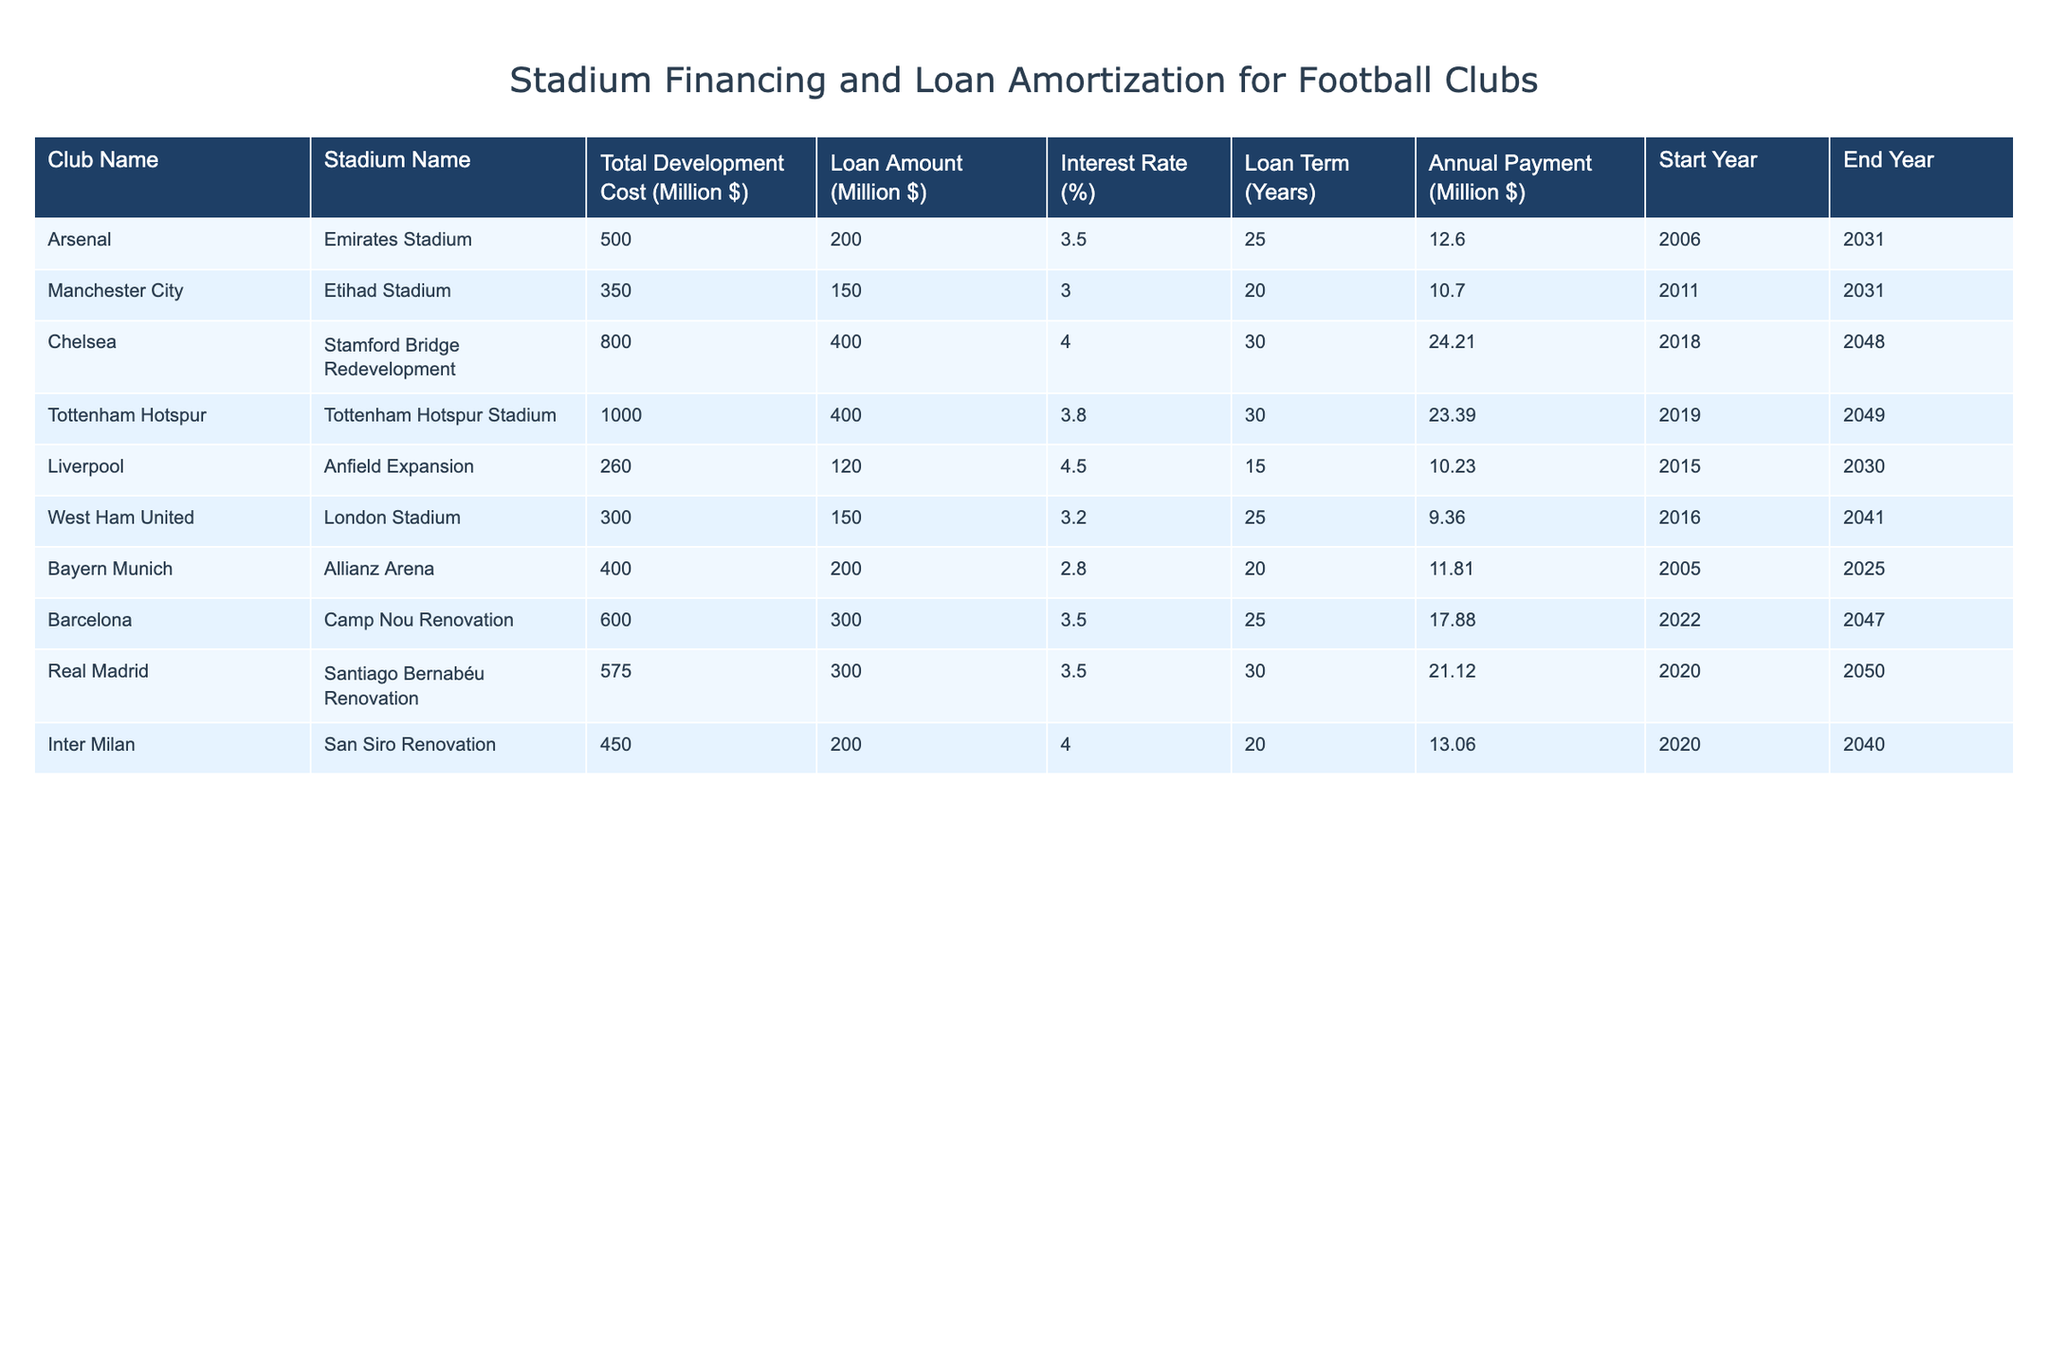What is the total development cost of the Tottenham Hotspur Stadium? The table indicates that the total development cost for the Tottenham Hotspur Stadium is listed directly in the column for 'Total Development Cost (Million $)'. It shows as 1000.
Answer: 1000 What is the loan amount for Chelsea's stadium redevelopment? By referring to the 'Loan Amount (Million $)' column for Chelsea, we can see that it is listed as 400.
Answer: 400 Which stadium has the highest interest rate on its loan? To determine this, we compare the 'Interest Rate (%)' across all listed stadiums. Chelsea's Stamford Bridge Redevelopment has the highest interest rate at 4.0%.
Answer: 4.0 What is the average annual payment for all clubs listed? The annual payments are given as: 12.60, 10.70, 24.21, 23.39, 10.23, 9.36, 11.81, 17.88, 21.12, 13.06. We sum these amounts: 12.60 + 10.70 + 24.21 + 23.39 + 10.23 + 9.36 + 11.81 + 17.88 + 21.12 + 13.06 =  144.06. Dividing by the number of clubs (10), we get an average of 14.41.
Answer: 14.41 Is Bayern Munich's Allianz Arena still under loan repayment as of 2023? Since the loan term is 20 years from the start year 2005, the loan will end in 2025, which means Bayern Munich is still in the repayment phase.
Answer: Yes How many clubs have a loan term greater than 25 years? From the table, we see that only Chelsea and Tottenham have loan terms of 30 years, resulting in a total of 2 clubs with a loan term greater than 25 years.
Answer: 2 What is the difference between the total development costs of Liverpool's Anfield Expansion and Arsenal's Emirates Stadium? The total development cost for Liverpool is 260 million dollars and for Arsenal, it is 500 million dollars. The difference is calculated as 500 - 260 = 240.
Answer: 240 Are any clubs scheduled to finish their loan repayment before 2030? By checking the 'End Year' column, we see Liverpool's loan will end in 2030, while others have end years of 2031 or later. Therefore, only Liverpool fits this criteria, indicating it will finish in exactly the year 2030.
Answer: Yes What percentage of the total development cost is financed through loans for Arsenal? Arsenal has a total development cost of 500 million and a loan amount of 200 million. The percentage is calculated as (200/500) * 100 = 40%.
Answer: 40% What is the total amount of loans taken by clubs that play in stadiums located in Germany? The only German club present in the table is Bayern Munich with a loan amount of 200 million. Hence the total loans taken by German clubs is just 200 million.
Answer: 200 